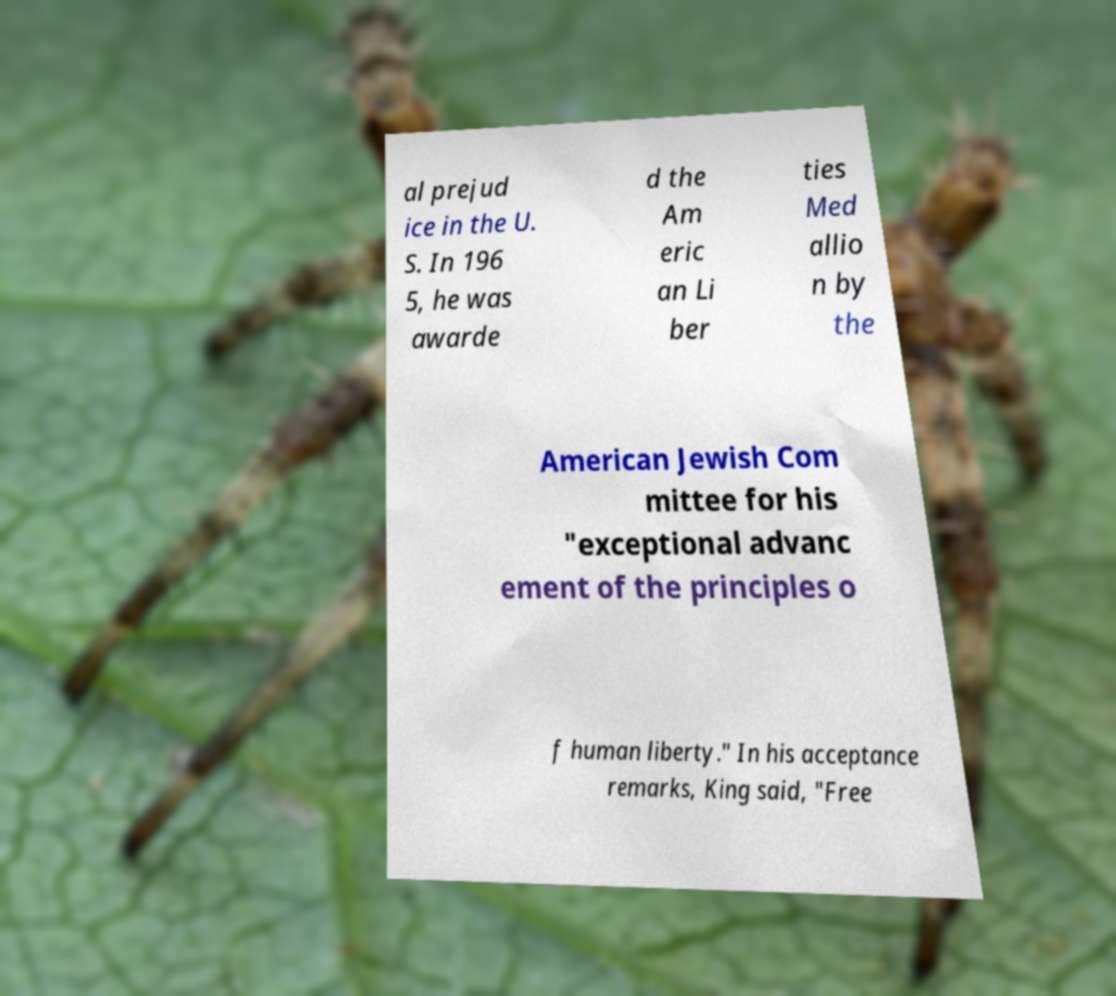I need the written content from this picture converted into text. Can you do that? al prejud ice in the U. S. In 196 5, he was awarde d the Am eric an Li ber ties Med allio n by the American Jewish Com mittee for his "exceptional advanc ement of the principles o f human liberty." In his acceptance remarks, King said, "Free 